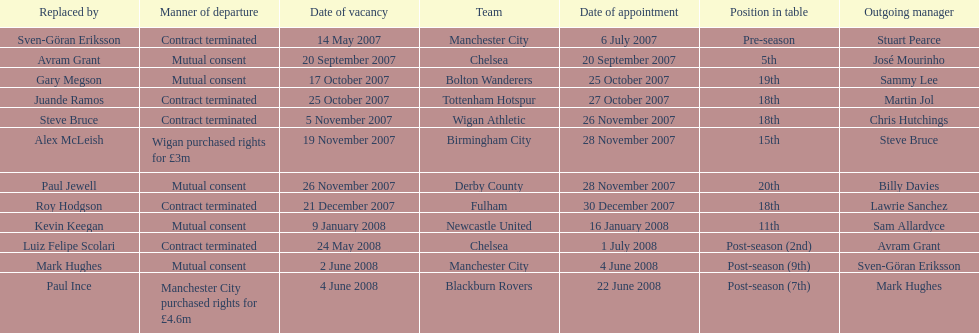How many teams had a manner of departure due to there contract being terminated? 5. 